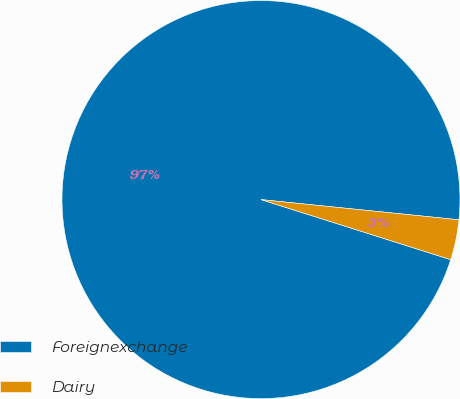Convert chart to OTSL. <chart><loc_0><loc_0><loc_500><loc_500><pie_chart><fcel>Foreignexchange<fcel>Dairy<nl><fcel>96.74%<fcel>3.26%<nl></chart> 